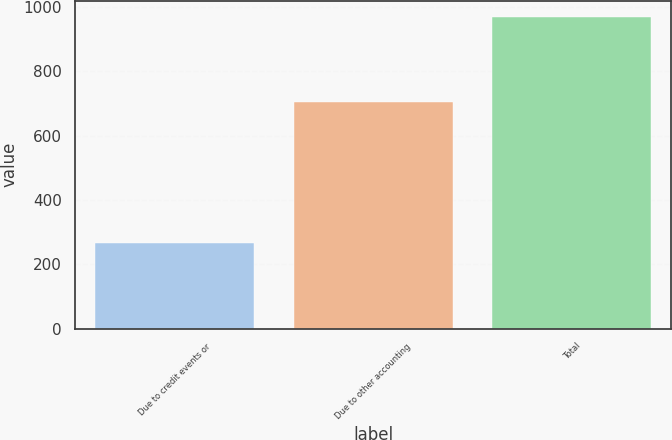<chart> <loc_0><loc_0><loc_500><loc_500><bar_chart><fcel>Due to credit events or<fcel>Due to other accounting<fcel>Total<nl><fcel>265<fcel>705<fcel>970<nl></chart> 